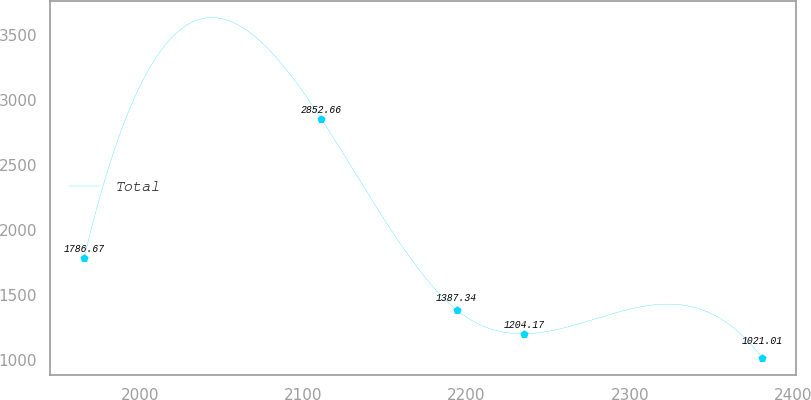Convert chart. <chart><loc_0><loc_0><loc_500><loc_500><line_chart><ecel><fcel>Total<nl><fcel>1965.95<fcel>1786.67<nl><fcel>2111.21<fcel>2852.66<nl><fcel>2193.93<fcel>1387.34<nl><fcel>2235.5<fcel>1204.17<nl><fcel>2380.9<fcel>1021.01<nl></chart> 